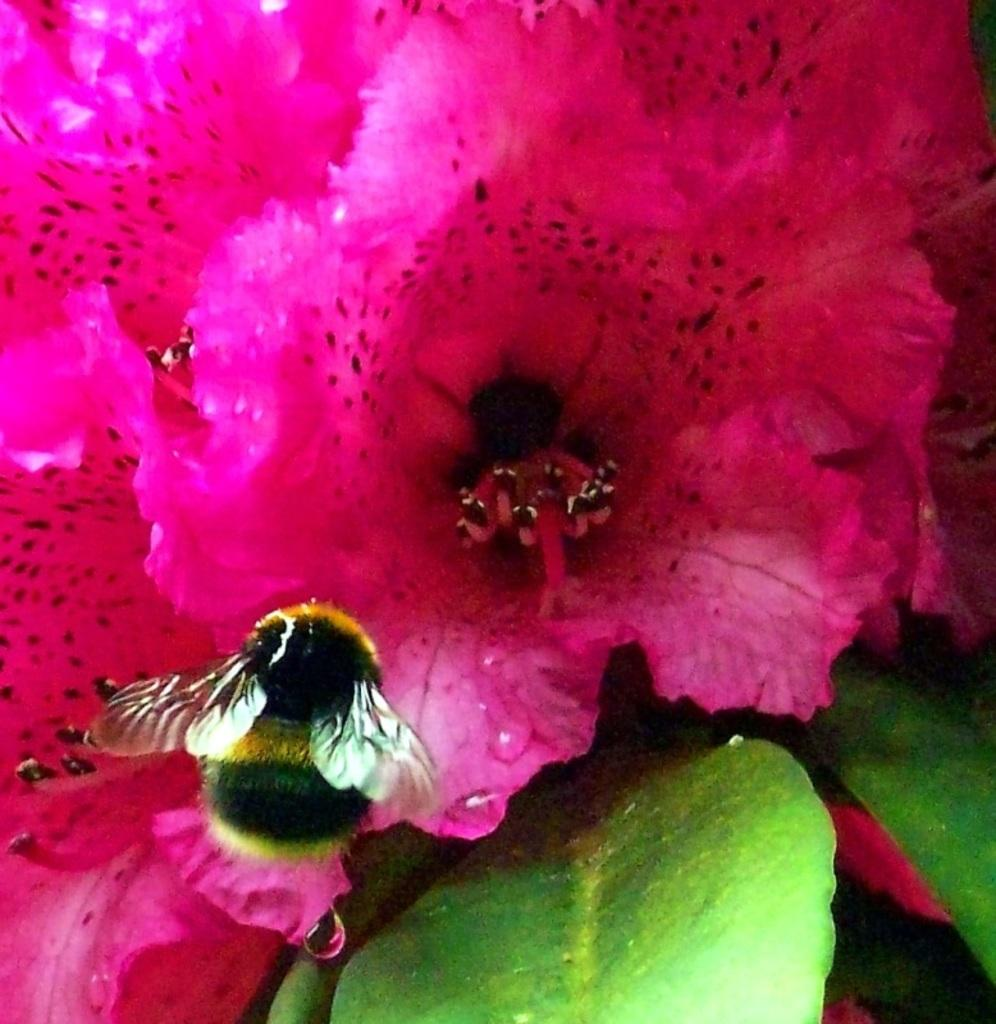What type of insect is in the image? There is a honey bee in the image. Where is the honey bee located? The honey bee is on a flower. What else can be seen in the image besides the honey bee? There are leaves visible in the image. How many times does the honey bee say "self" in the image? The honey bee does not speak in the image, so it cannot say "self" or any other word. 